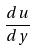<formula> <loc_0><loc_0><loc_500><loc_500>\frac { d u } { d y }</formula> 